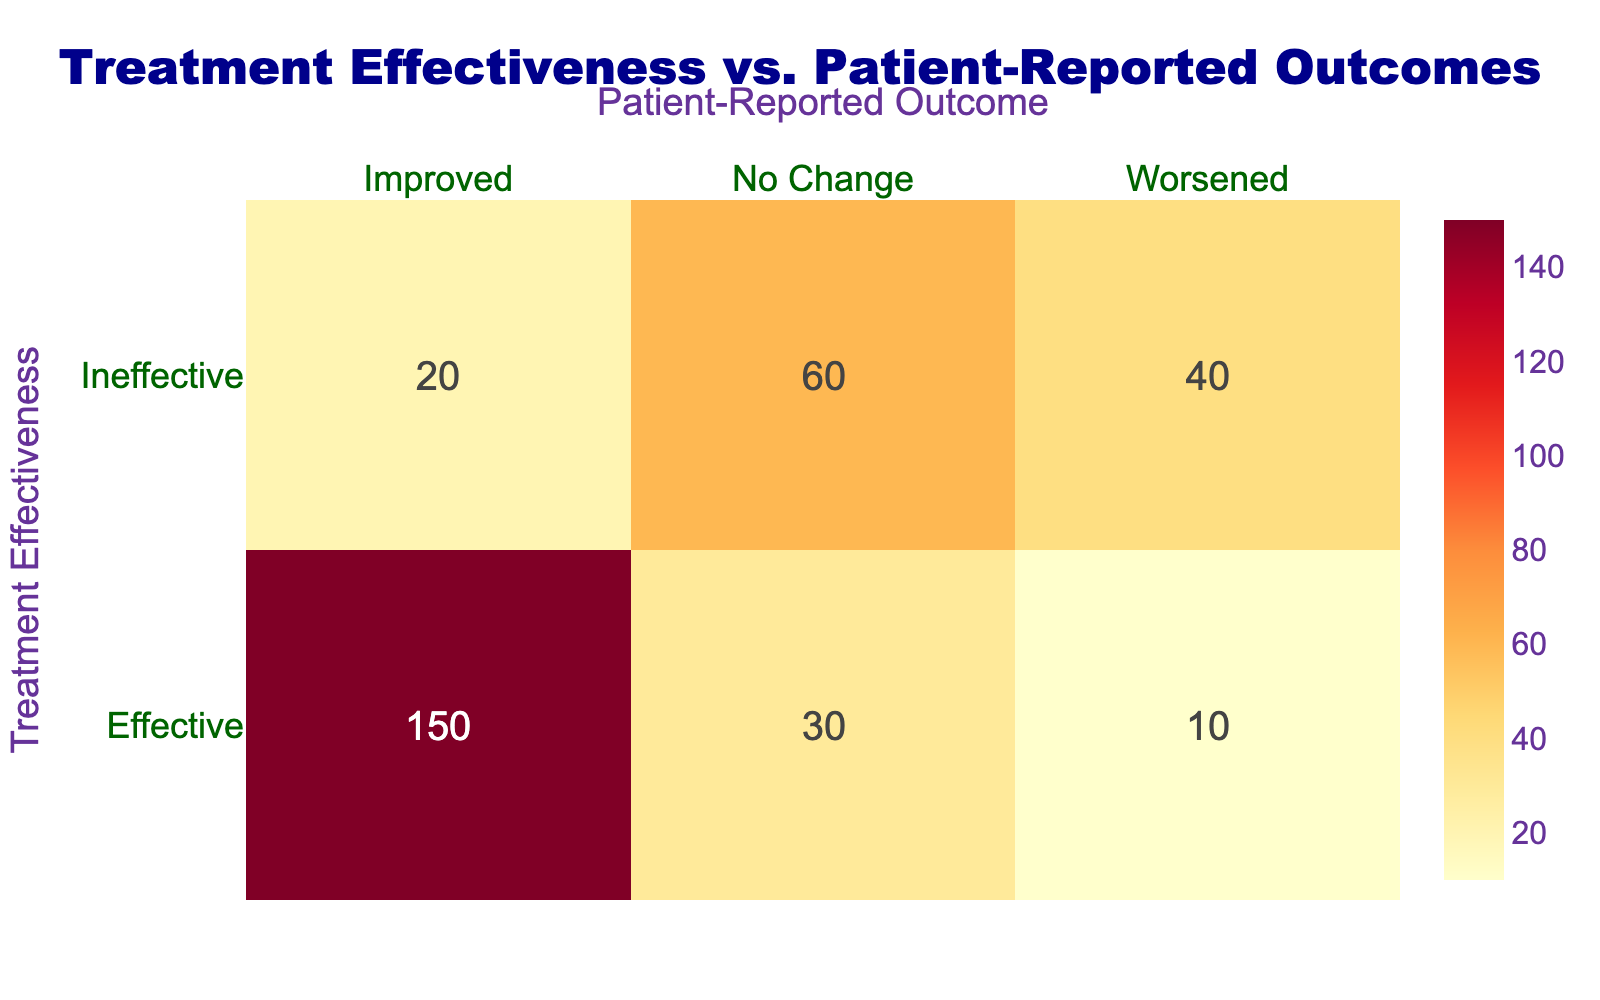What is the total number of patients who reported an improved outcome after treatment? To find the total number of patients who reported an improved outcome, we need to look at the row for both "Effective" and "Ineffective" treatment where the outcome is "Improved." Adding the counts: 150 (Effective, Improved) + 20 (Ineffective, Improved) = 170.
Answer: 170 How many patients experienced no change in their condition after ineffective treatment? The number of patients who experienced no change after ineffective treatment is directly provided in the table as 60.
Answer: 60 What is the difference in the number of patients who worsened under effective vs. ineffective treatment? To find the difference, we first note the counts: there are 10 patients who worsened after effective treatment and 40 patients who worsened after ineffective treatment. Therefore, the difference is 40 (Ineffective, Worsened) - 10 (Effective, Worsened) = 30.
Answer: 30 What percentage of patients reported an improved outcome after effective treatment compared to all patients who were treated effectively? First, calculate the total number of patients treated effectively: 150 (Improved) + 30 (No Change) + 10 (Worsened) = 190. The number of patients who reported an improved outcome after effective treatment is 150. Now, the percentage is (150 / 190) * 100 ≈ 78.95%.
Answer: 78.95% Is it true that more patients reported being worsened under ineffective treatment than under effective treatment? To determine this, we compare the counts: 40 patients worsened after ineffective treatment, while 10 patients worsened under effective treatment. Since 40 is greater than 10, the statement is true.
Answer: Yes What is the total number of patients who experienced any outcome (Improved, No Change, Worsened) under ineffective treatment? Summing the counts for all outcomes under ineffective treatment: 20 (Improved) + 60 (No Change) + 40 (Worsened) = 120.
Answer: 120 What is the total count of patients who experienced a change (Improved or Worsened) after treatment? To find the total count of patients who experienced a change, we include all "Improved" and "Worsened" outcomes. Effective treatment (150 + 10 = 160) and Ineffective treatment (20 + 40 = 60). Thus, 160 (Effective) + 60 (Ineffective) = 220.
Answer: 220 How many patients were categorized as experiencing worsened outcomes in total? Adding both rows that report worsened outcomes gives the total: 10 patients (Effective) + 40 patients (Ineffective) = 50 patients overall.
Answer: 50 